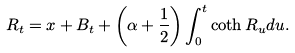Convert formula to latex. <formula><loc_0><loc_0><loc_500><loc_500>R _ { t } = x + B _ { t } + \left ( \alpha + \frac { 1 } { 2 } \right ) \int _ { 0 } ^ { t } \coth R _ { u } d u .</formula> 